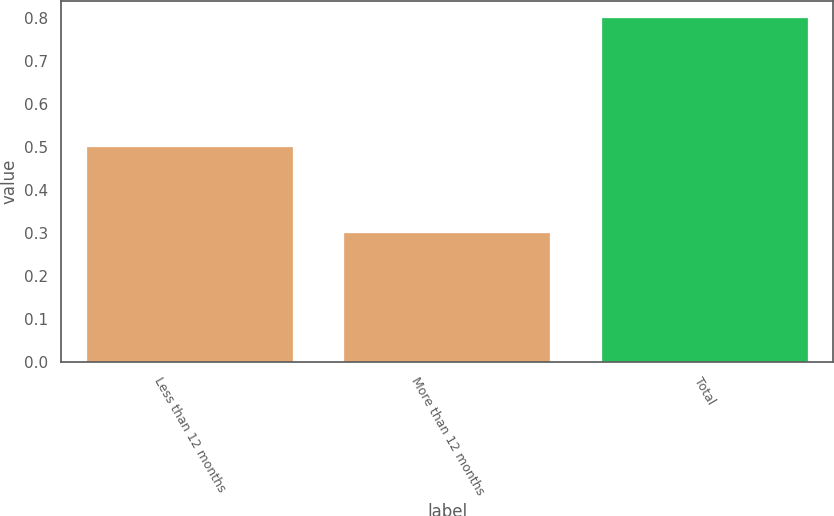<chart> <loc_0><loc_0><loc_500><loc_500><bar_chart><fcel>Less than 12 months<fcel>More than 12 months<fcel>Total<nl><fcel>0.5<fcel>0.3<fcel>0.8<nl></chart> 